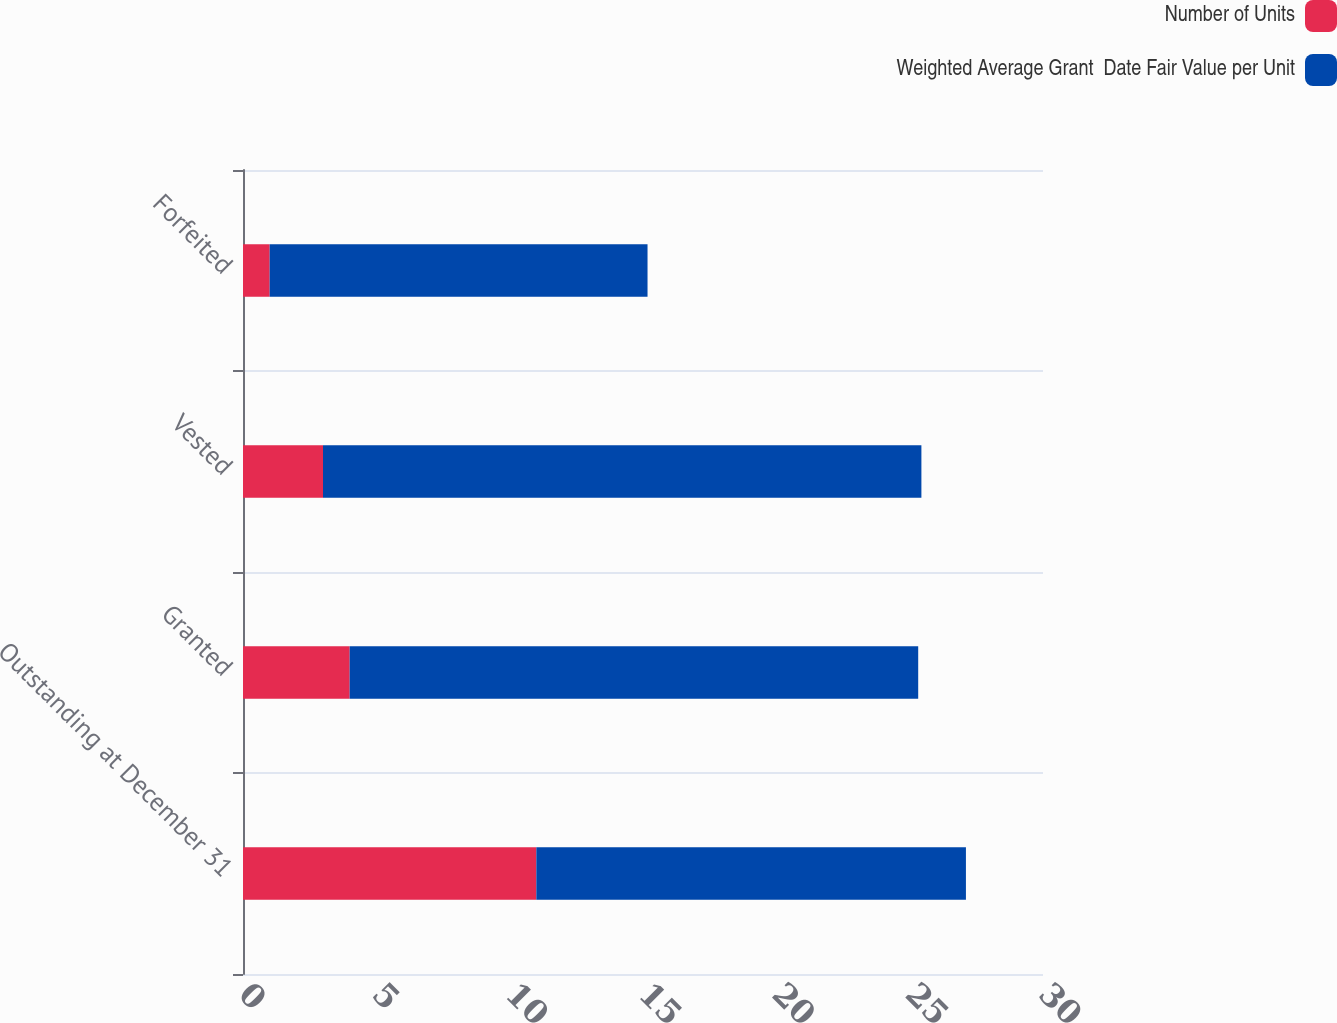Convert chart to OTSL. <chart><loc_0><loc_0><loc_500><loc_500><stacked_bar_chart><ecel><fcel>Outstanding at December 31<fcel>Granted<fcel>Vested<fcel>Forfeited<nl><fcel>Number of Units<fcel>11<fcel>4<fcel>3<fcel>1<nl><fcel>Weighted Average Grant  Date Fair Value per Unit<fcel>16.11<fcel>21.32<fcel>22.44<fcel>14.17<nl></chart> 